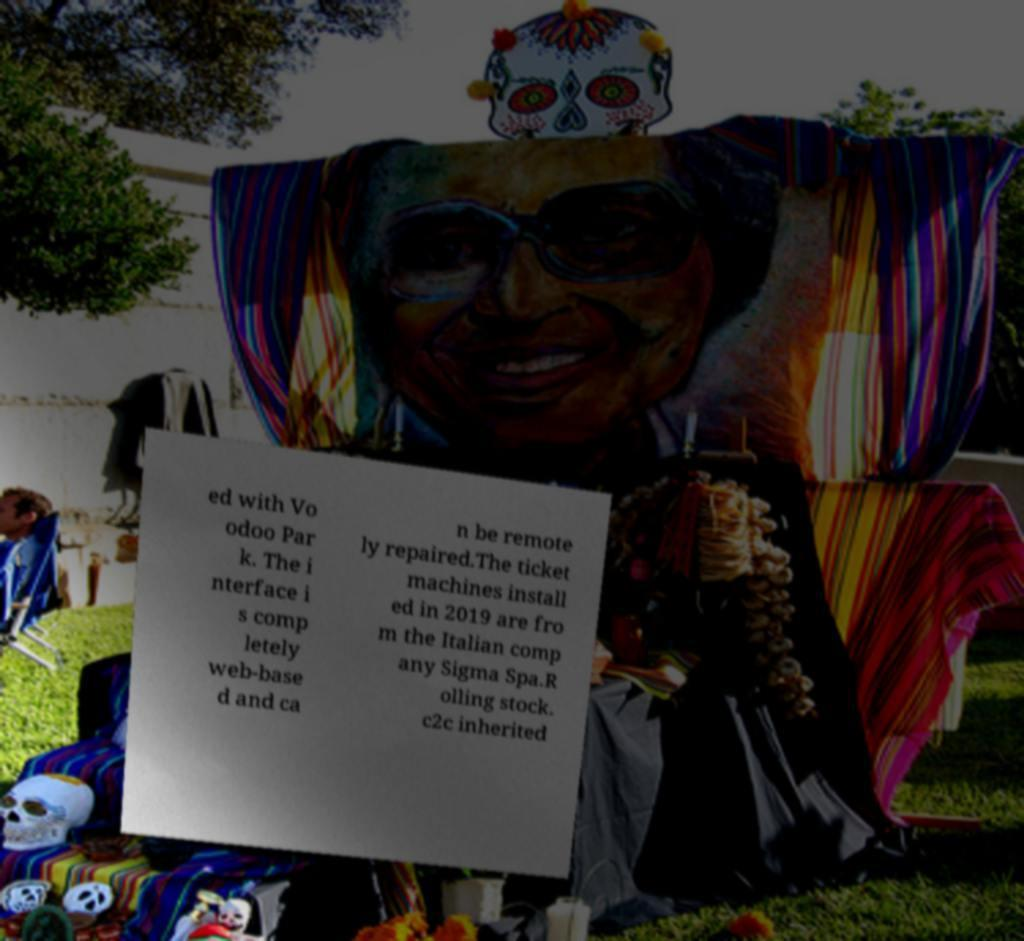There's text embedded in this image that I need extracted. Can you transcribe it verbatim? ed with Vo odoo Par k. The i nterface i s comp letely web-base d and ca n be remote ly repaired.The ticket machines install ed in 2019 are fro m the Italian comp any Sigma Spa.R olling stock. c2c inherited 